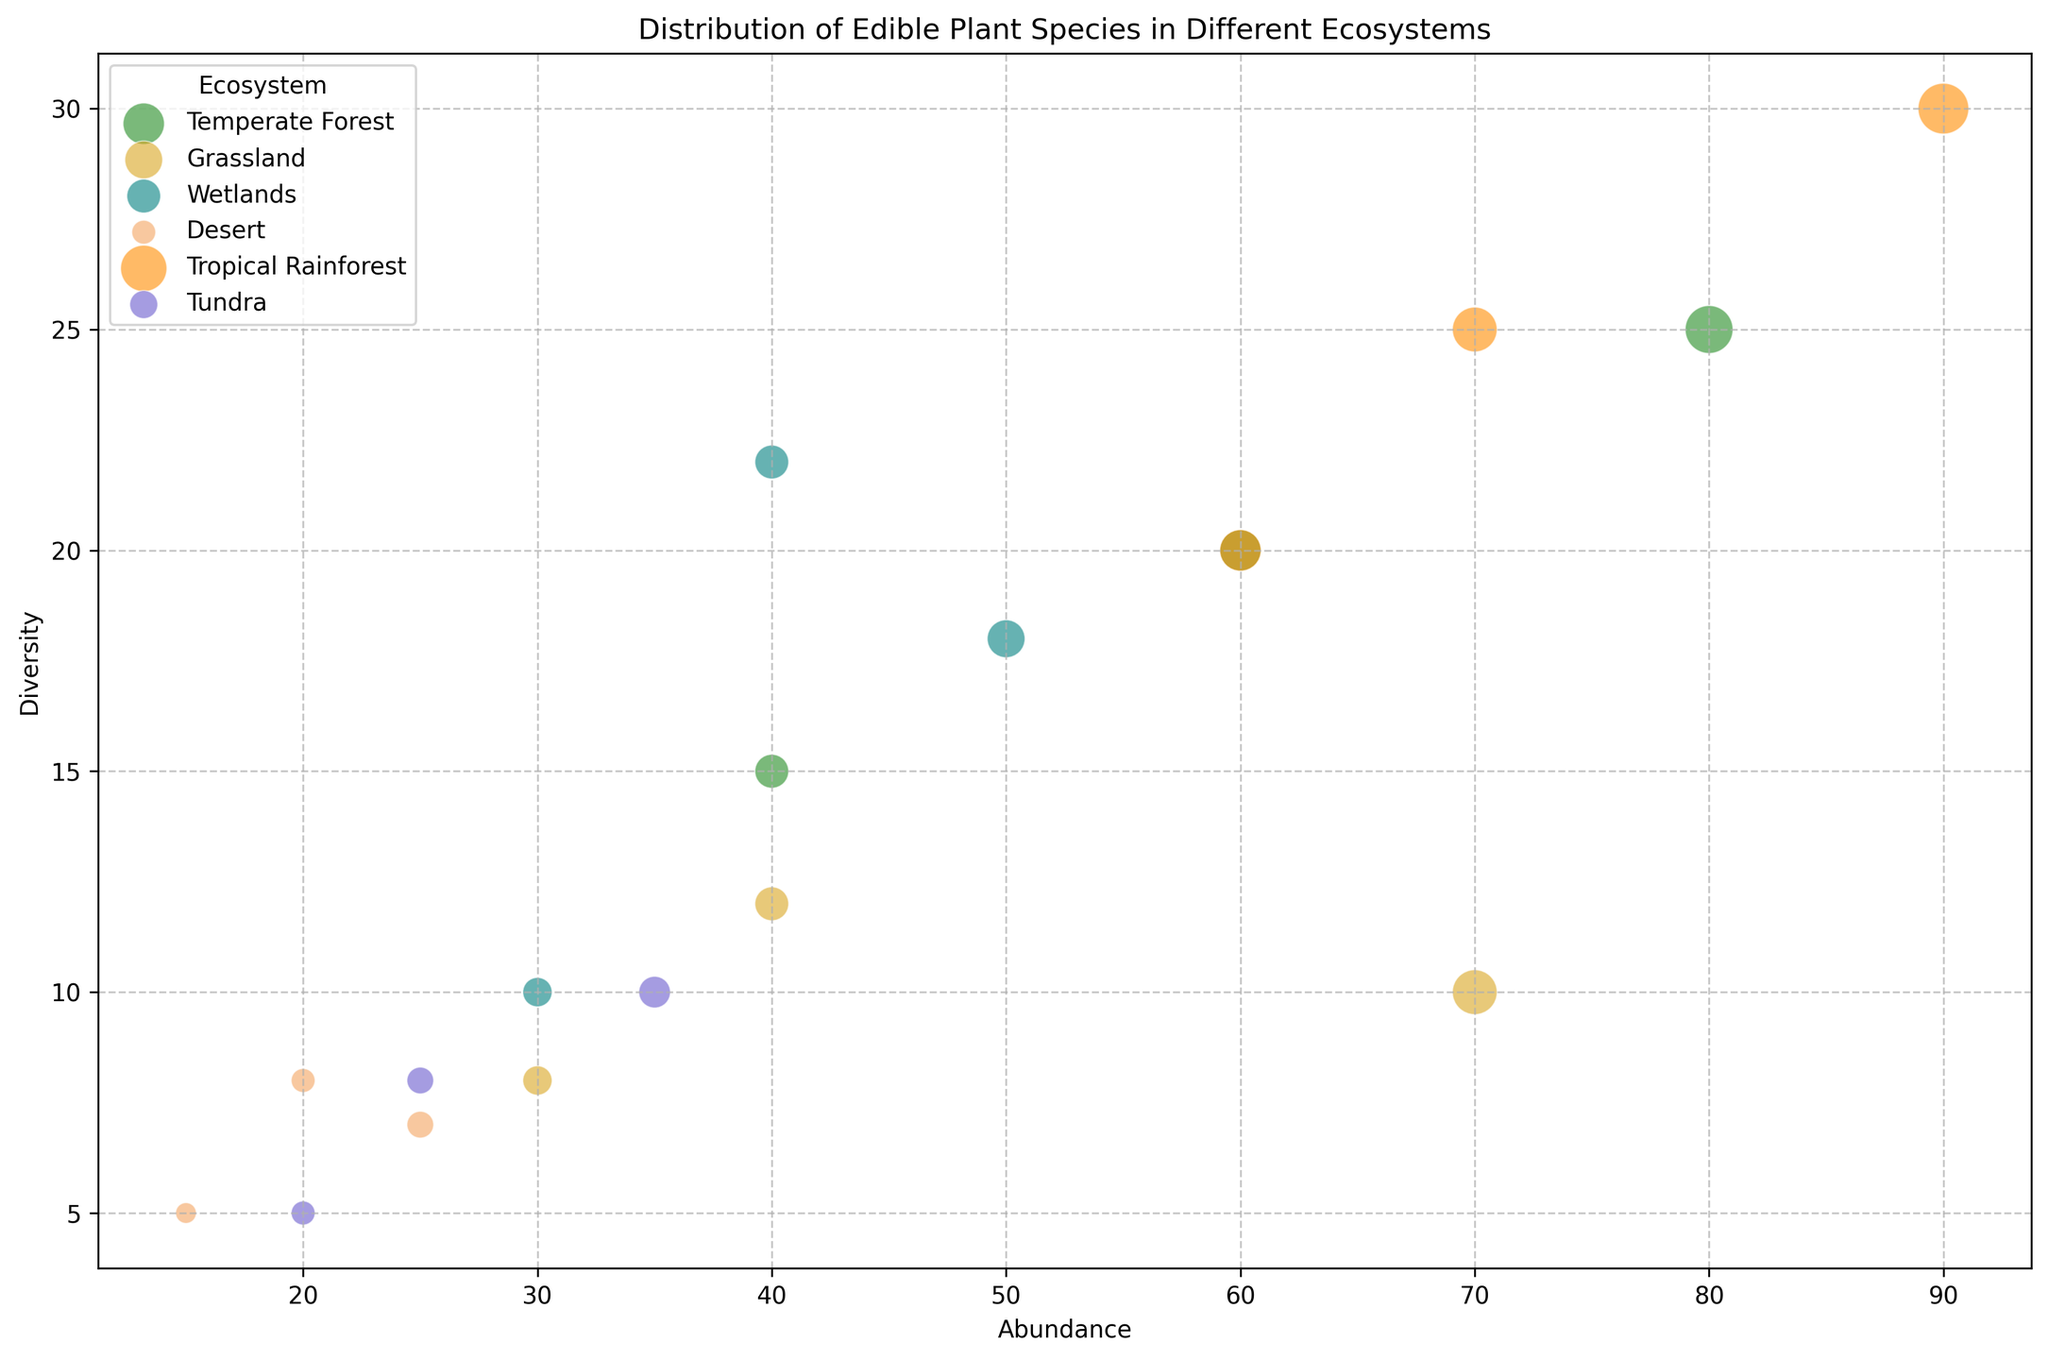Which ecosystem has the highest abundance of edible plant species? Look at the x-axis to find the largest bubble placement. The Tropical Rainforest ecosystem has the largest value on the x-axis reaching 90.
Answer: Tropical Rainforest Which edible plant species in Temperate Forest has the highest diversity? Identify the different species within the Temperate Forest by their colors and locate the one with the highest y-axis value. "Wild Berries" reaches a y-axis value of 25, which is the highest among other species in Temperate Forest.
Answer: Wild Berries Compare the abundance of Wild Berries in Temperate Forest with Berries in Wetlands. Which one is higher, and by how much? Look at the x-axis of bubbles for Wild Berries in Temperate Forest and Berries in Wetlands. Wild Berries has an abundance value of 80, and Berries in Wetlands has 30. Calculate the difference: 80 - 30 = 50.
Answer: Wild Berries in Temperate Forest is higher by 50 What is the total abundance of all edible plant species in the Wetlands ecosystem? Add up the abundance values of all plant species in Wetlands: 50 (Edible Tubers) + 40 (Aquatic Plants) + 30 (Berries) = 120.
Answer: 120 Which ecosystem has the most diverse (highest y-value) edible plant species, and what species is it? Identify which bubble reaches the highest point on the y-axis, indicating the highest diversity. The Tropical Rainforest ecosystem has the bubble "Fruits" with a diversity value of 30.
Answer: Tropical Rainforest, Fruits Which ecosystem is represented by bubbles in the color green? Identify the color forest green on the plot and check the labeled ecosystems for this color, which corresponds to the Temperate Forest.
Answer: Temperate Forest Compare the diversity of Edible Mushrooms in Temperate Forest and Nuts in Tropical Rainforest. Which one is more diverse? Check the y-axis values of bubbles for Edible Mushrooms in Temperate Forest and Nuts in Tropical Rainforest. Edible Mushrooms have a diversity of 20, and Nuts have 20.
Answer: They have equal diversity Is there any plant species in Desert that has a higher diversity than Edible Leaves in Tropical Rainforest? Compare the y-axis values of species in Desert with Edible Leaves in Tropical Rainforest. Edible Leaves has a diversity of 25, higher than all species in Desert, where the highest diversity value is 8.
Answer: No What is the difference in abundance between Root Vegetables in Grassland and Edible Tubers in Wetlands? Look at the x-axis values: Root Vegetables in Grassland have an abundance of 30, and Edible Tubers in Wetlands have 50. Calculate the difference: 50 - 30 = 20.
Answer: 20 